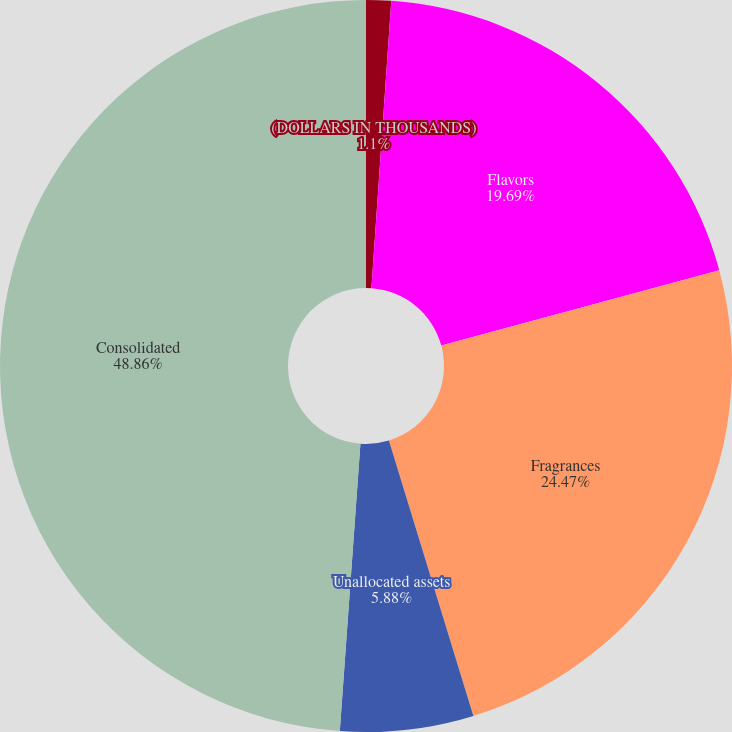Convert chart. <chart><loc_0><loc_0><loc_500><loc_500><pie_chart><fcel>(DOLLARS IN THOUSANDS)<fcel>Flavors<fcel>Fragrances<fcel>Unallocated assets<fcel>Consolidated<nl><fcel>1.1%<fcel>19.69%<fcel>24.47%<fcel>5.88%<fcel>48.86%<nl></chart> 